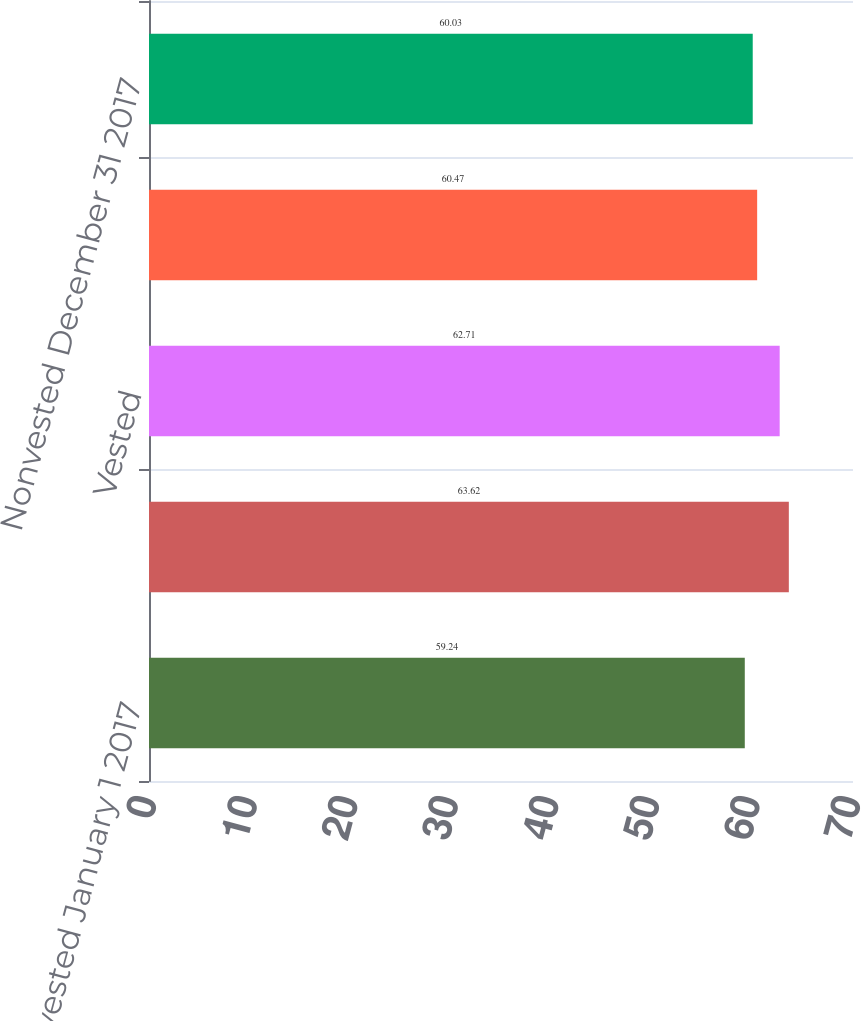<chart> <loc_0><loc_0><loc_500><loc_500><bar_chart><fcel>Nonvested January 1 2017<fcel>Granted<fcel>Vested<fcel>Forfeited<fcel>Nonvested December 31 2017<nl><fcel>59.24<fcel>63.62<fcel>62.71<fcel>60.47<fcel>60.03<nl></chart> 